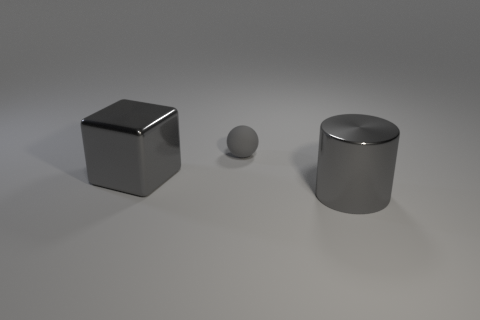Is there anything else that has the same color as the shiny cube?
Provide a succinct answer. Yes. There is a tiny ball; is its color the same as the object that is left of the gray ball?
Ensure brevity in your answer.  Yes. Are there fewer large metallic cubes to the right of the gray block than tiny gray objects?
Offer a terse response. Yes. There is a object behind the large block; what is its material?
Offer a terse response. Rubber. What number of other things are the same size as the metallic cylinder?
Provide a short and direct response. 1. There is a metallic block; does it have the same size as the thing that is on the right side of the small thing?
Make the answer very short. Yes. There is a gray metallic thing that is left of the large metallic object to the right of the metal thing that is to the left of the tiny matte object; what is its shape?
Keep it short and to the point. Cube. Is the number of large cylinders less than the number of red metallic balls?
Offer a very short reply. No. Are there any large gray metallic objects behind the gray metallic cylinder?
Give a very brief answer. Yes. The thing that is behind the large cylinder and to the right of the gray metallic block has what shape?
Provide a short and direct response. Sphere. 